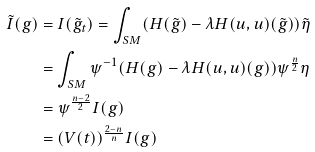<formula> <loc_0><loc_0><loc_500><loc_500>\tilde { I } ( g ) & = I ( \tilde { g } _ { t } ) = \int _ { S M } ( H ( \tilde { g } ) - \lambda H ( u , u ) ( \tilde { g } ) ) \tilde { \eta } \\ & = \int _ { S M } \psi ^ { - 1 } ( H ( g ) - \lambda H ( u , u ) ( g ) ) \psi ^ { \frac { n } { 2 } } \eta \\ & = \psi ^ { \frac { n - 2 } { 2 } } I ( g ) \\ & = ( V ( t ) ) ^ { \frac { 2 - n } { n } } I ( g )</formula> 